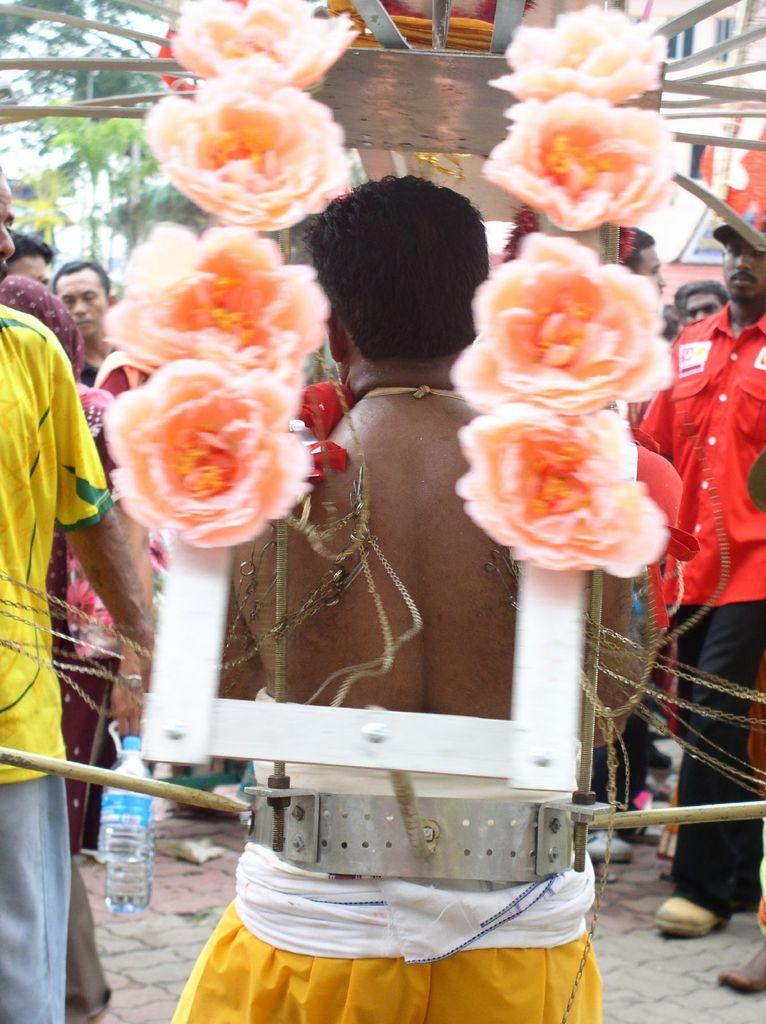What is happening with the group of people in the image? There is a group of people on the ground in the image. What can be seen surrounding the people in the image? There is a frame, a bottle, flowers, and sticks in the image. What else is present in the image besides the people and objects mentioned? There are other objects in the image. What can be seen in the background of the image? There are trees in the background of the image. What type of care is being provided to the flowers in the image? There is no indication of care being provided to the flowers in the image. 